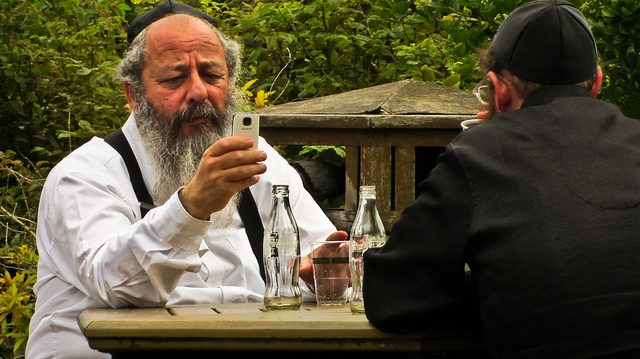Describe the objects in this image and their specific colors. I can see people in darkgreen, black, maroon, and gray tones, people in darkgreen, lightgray, darkgray, black, and maroon tones, dining table in darkgreen, black, and tan tones, bottle in darkgreen, darkgray, lightgray, beige, and tan tones, and bottle in darkgreen, tan, beige, and olive tones in this image. 